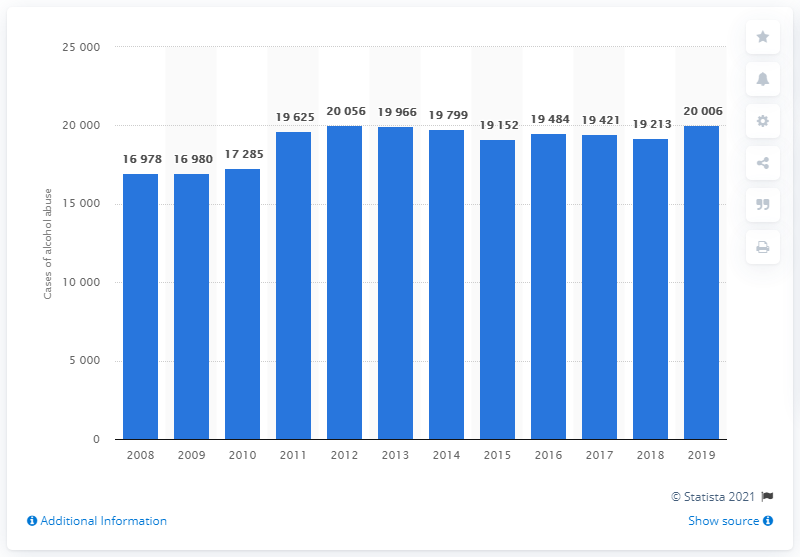Highlight a few significant elements in this photo. In 2019, there were 20006 cases of alcohol abuse in Belgium. In the year 2011, there were fewer cases of alcohol abuse reported in Belgium. 